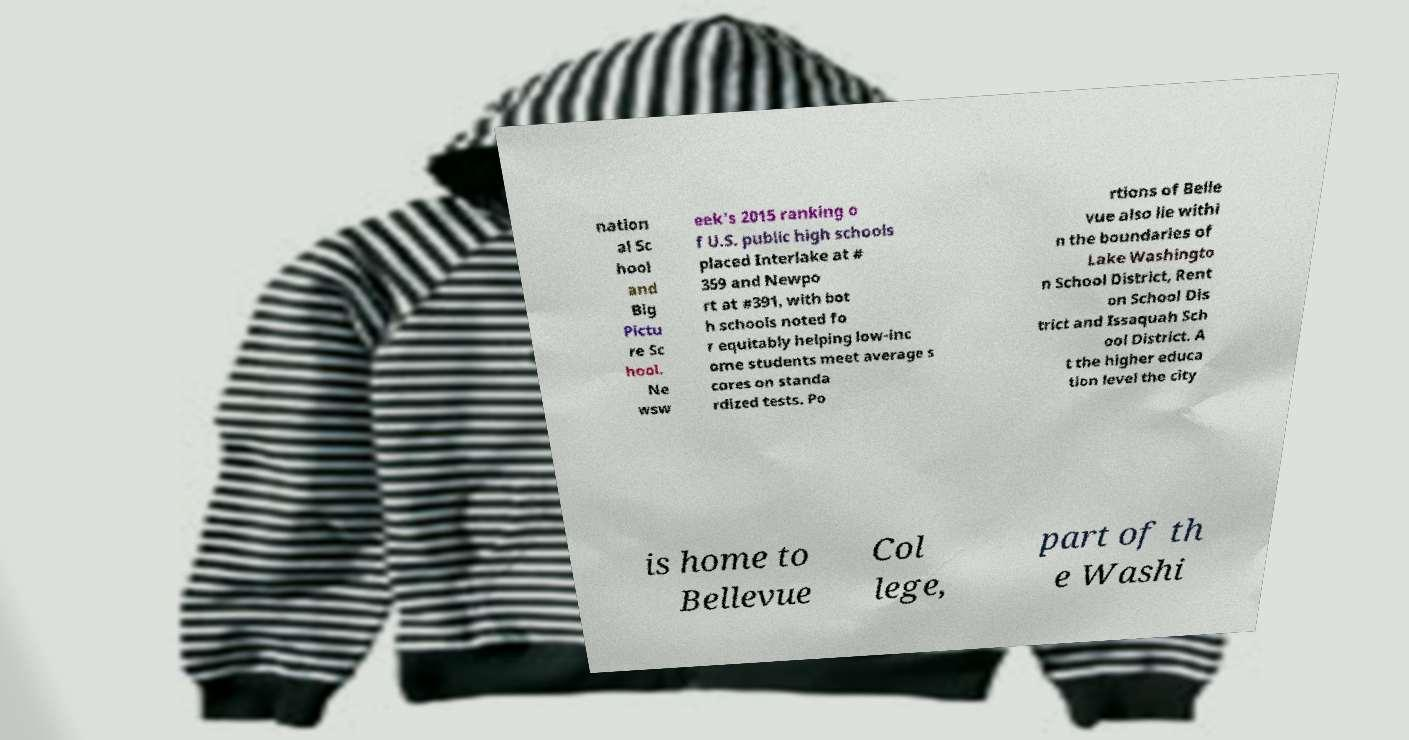Can you read and provide the text displayed in the image?This photo seems to have some interesting text. Can you extract and type it out for me? nation al Sc hool and Big Pictu re Sc hool. Ne wsw eek's 2015 ranking o f U.S. public high schools placed Interlake at # 359 and Newpo rt at #391, with bot h schools noted fo r equitably helping low-inc ome students meet average s cores on standa rdized tests. Po rtions of Belle vue also lie withi n the boundaries of Lake Washingto n School District, Rent on School Dis trict and Issaquah Sch ool District. A t the higher educa tion level the city is home to Bellevue Col lege, part of th e Washi 